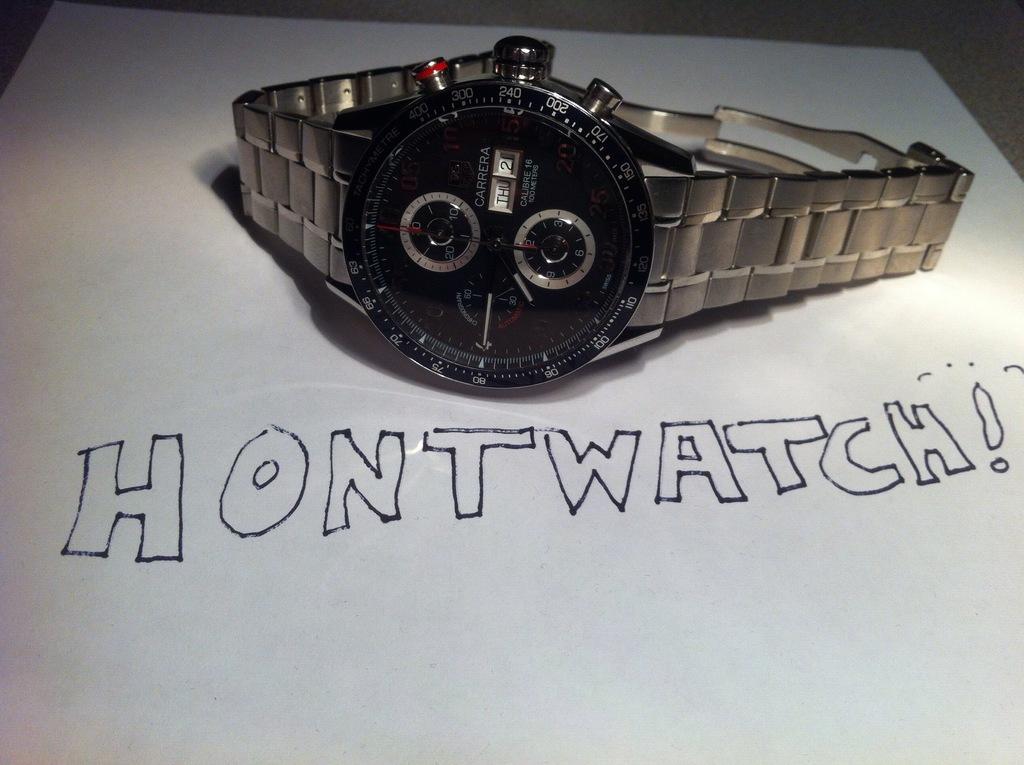According to the watch, what day of the week is it?
Your answer should be very brief. Thursday. What it is?
Your answer should be compact. Hontwatch. 